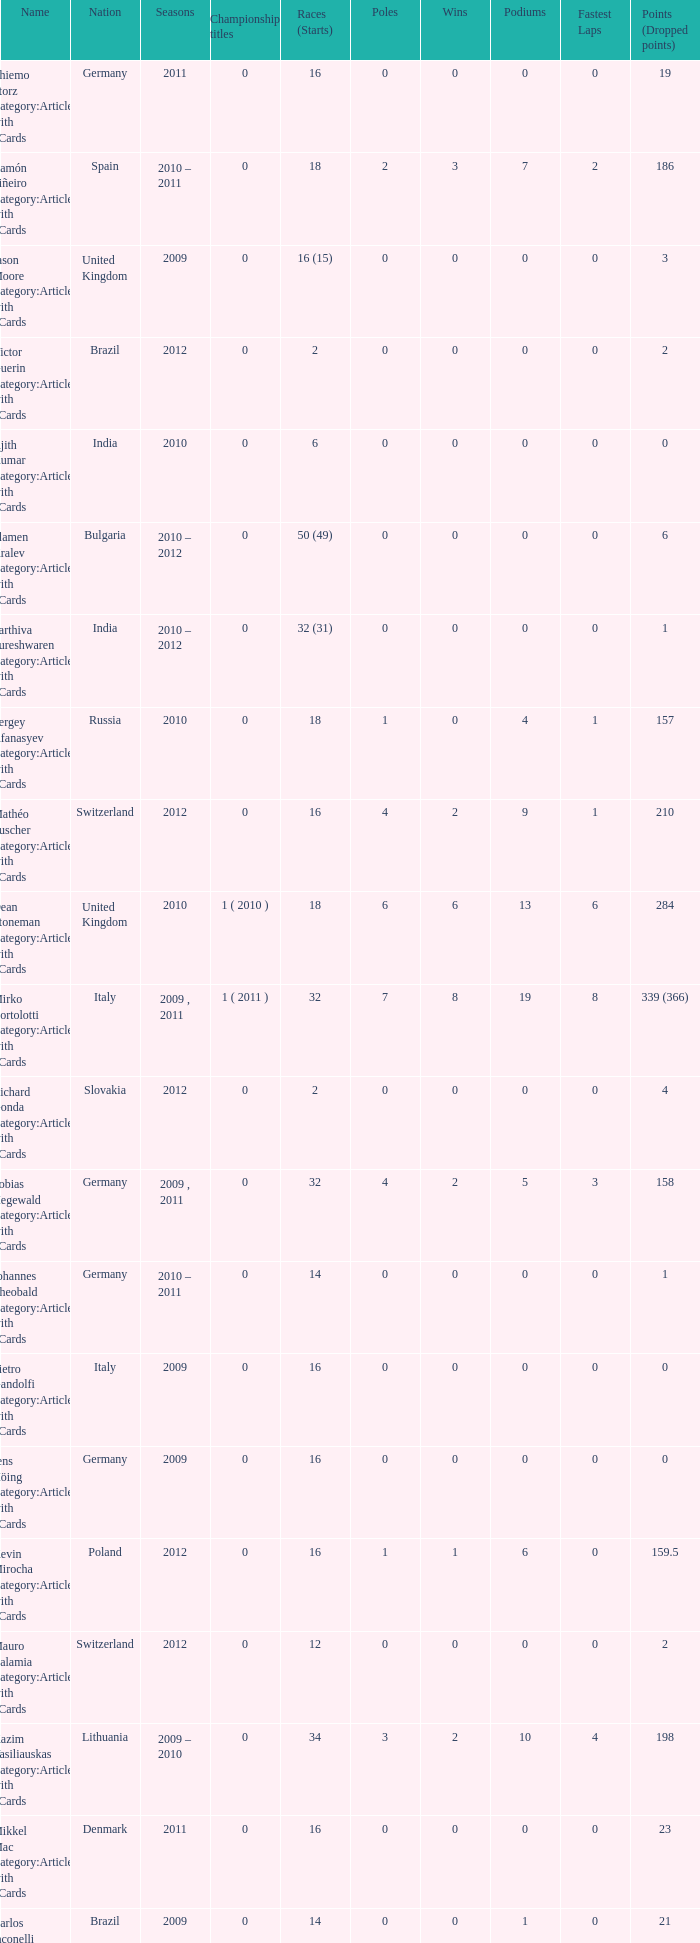What was the least amount of wins? 0.0. 